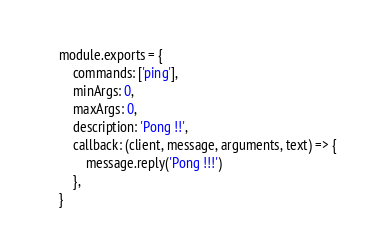<code> <loc_0><loc_0><loc_500><loc_500><_JavaScript_>module.exports = {
    commands: ['ping'],
    minArgs: 0,
    maxArgs: 0,
    description: 'Pong !!',
    callback: (client, message, arguments, text) => {
        message.reply('Pong !!!')
    },
}</code> 